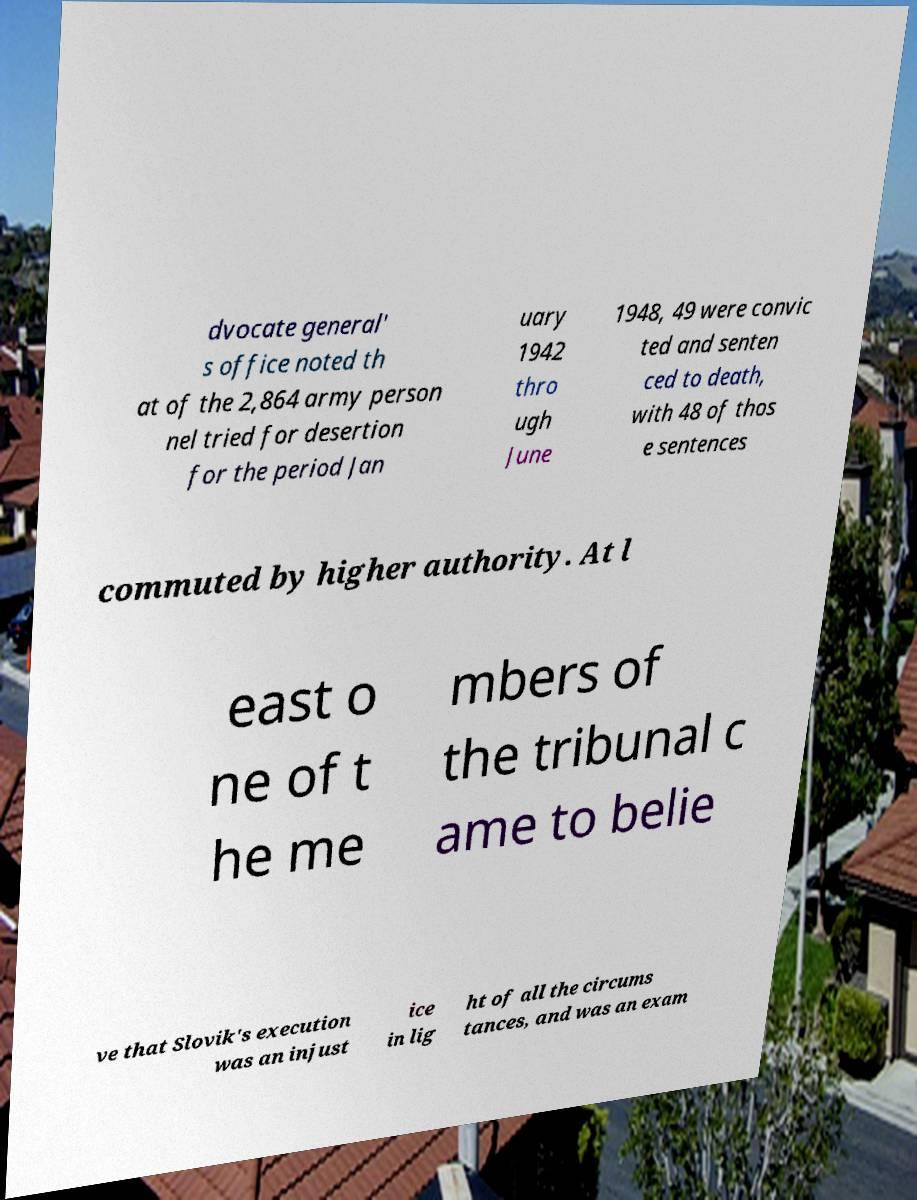Can you read and provide the text displayed in the image?This photo seems to have some interesting text. Can you extract and type it out for me? dvocate general' s office noted th at of the 2,864 army person nel tried for desertion for the period Jan uary 1942 thro ugh June 1948, 49 were convic ted and senten ced to death, with 48 of thos e sentences commuted by higher authority. At l east o ne of t he me mbers of the tribunal c ame to belie ve that Slovik's execution was an injust ice in lig ht of all the circums tances, and was an exam 